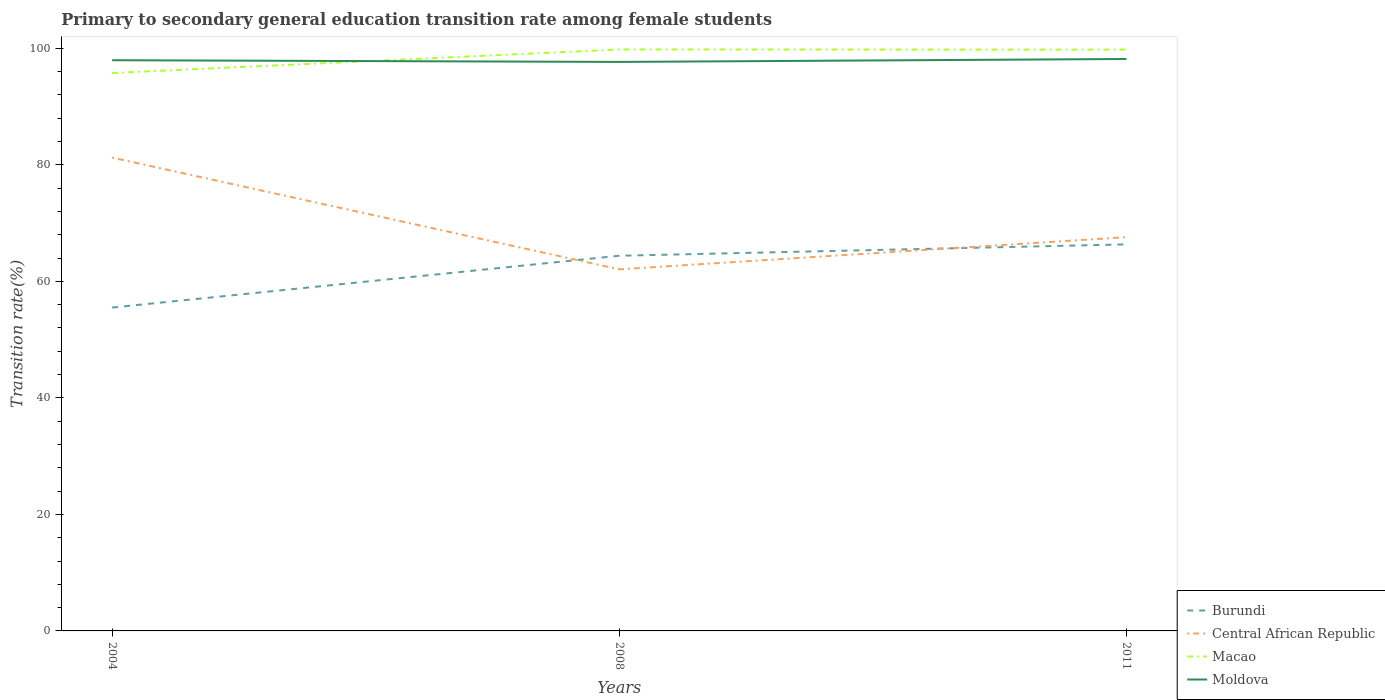How many different coloured lines are there?
Your response must be concise. 4. Does the line corresponding to Burundi intersect with the line corresponding to Central African Republic?
Ensure brevity in your answer.  Yes. Is the number of lines equal to the number of legend labels?
Give a very brief answer. Yes. Across all years, what is the maximum transition rate in Macao?
Keep it short and to the point. 95.75. In which year was the transition rate in Macao maximum?
Offer a terse response. 2004. What is the total transition rate in Burundi in the graph?
Offer a very short reply. -8.89. What is the difference between the highest and the second highest transition rate in Macao?
Your response must be concise. 4.04. What is the difference between the highest and the lowest transition rate in Burundi?
Offer a terse response. 2. What is the difference between two consecutive major ticks on the Y-axis?
Make the answer very short. 20. Are the values on the major ticks of Y-axis written in scientific E-notation?
Give a very brief answer. No. Does the graph contain grids?
Provide a succinct answer. No. Where does the legend appear in the graph?
Keep it short and to the point. Bottom right. How many legend labels are there?
Make the answer very short. 4. What is the title of the graph?
Your answer should be very brief. Primary to secondary general education transition rate among female students. What is the label or title of the X-axis?
Give a very brief answer. Years. What is the label or title of the Y-axis?
Keep it short and to the point. Transition rate(%). What is the Transition rate(%) of Burundi in 2004?
Offer a terse response. 55.49. What is the Transition rate(%) of Central African Republic in 2004?
Your answer should be compact. 81.23. What is the Transition rate(%) of Macao in 2004?
Ensure brevity in your answer.  95.75. What is the Transition rate(%) of Moldova in 2004?
Your response must be concise. 97.95. What is the Transition rate(%) of Burundi in 2008?
Your answer should be very brief. 64.39. What is the Transition rate(%) in Central African Republic in 2008?
Make the answer very short. 62.06. What is the Transition rate(%) in Macao in 2008?
Provide a short and direct response. 99.79. What is the Transition rate(%) in Moldova in 2008?
Your response must be concise. 97.65. What is the Transition rate(%) of Burundi in 2011?
Your answer should be compact. 66.34. What is the Transition rate(%) in Central African Republic in 2011?
Keep it short and to the point. 67.58. What is the Transition rate(%) in Macao in 2011?
Offer a very short reply. 99.76. What is the Transition rate(%) of Moldova in 2011?
Provide a short and direct response. 98.16. Across all years, what is the maximum Transition rate(%) of Burundi?
Provide a short and direct response. 66.34. Across all years, what is the maximum Transition rate(%) of Central African Republic?
Provide a succinct answer. 81.23. Across all years, what is the maximum Transition rate(%) in Macao?
Your answer should be very brief. 99.79. Across all years, what is the maximum Transition rate(%) in Moldova?
Provide a short and direct response. 98.16. Across all years, what is the minimum Transition rate(%) of Burundi?
Provide a short and direct response. 55.49. Across all years, what is the minimum Transition rate(%) of Central African Republic?
Your answer should be very brief. 62.06. Across all years, what is the minimum Transition rate(%) of Macao?
Your answer should be compact. 95.75. Across all years, what is the minimum Transition rate(%) of Moldova?
Provide a short and direct response. 97.65. What is the total Transition rate(%) in Burundi in the graph?
Offer a very short reply. 186.22. What is the total Transition rate(%) of Central African Republic in the graph?
Your answer should be very brief. 210.87. What is the total Transition rate(%) of Macao in the graph?
Your answer should be compact. 295.3. What is the total Transition rate(%) of Moldova in the graph?
Provide a succinct answer. 293.75. What is the difference between the Transition rate(%) in Burundi in 2004 and that in 2008?
Provide a short and direct response. -8.89. What is the difference between the Transition rate(%) in Central African Republic in 2004 and that in 2008?
Give a very brief answer. 19.18. What is the difference between the Transition rate(%) of Macao in 2004 and that in 2008?
Offer a terse response. -4.04. What is the difference between the Transition rate(%) of Moldova in 2004 and that in 2008?
Your response must be concise. 0.29. What is the difference between the Transition rate(%) in Burundi in 2004 and that in 2011?
Provide a short and direct response. -10.84. What is the difference between the Transition rate(%) in Central African Republic in 2004 and that in 2011?
Provide a short and direct response. 13.65. What is the difference between the Transition rate(%) in Macao in 2004 and that in 2011?
Keep it short and to the point. -4.01. What is the difference between the Transition rate(%) in Moldova in 2004 and that in 2011?
Give a very brief answer. -0.21. What is the difference between the Transition rate(%) in Burundi in 2008 and that in 2011?
Provide a succinct answer. -1.95. What is the difference between the Transition rate(%) of Central African Republic in 2008 and that in 2011?
Your response must be concise. -5.53. What is the difference between the Transition rate(%) of Macao in 2008 and that in 2011?
Ensure brevity in your answer.  0.02. What is the difference between the Transition rate(%) in Moldova in 2008 and that in 2011?
Your response must be concise. -0.5. What is the difference between the Transition rate(%) in Burundi in 2004 and the Transition rate(%) in Central African Republic in 2008?
Provide a short and direct response. -6.56. What is the difference between the Transition rate(%) of Burundi in 2004 and the Transition rate(%) of Macao in 2008?
Ensure brevity in your answer.  -44.29. What is the difference between the Transition rate(%) of Burundi in 2004 and the Transition rate(%) of Moldova in 2008?
Ensure brevity in your answer.  -42.16. What is the difference between the Transition rate(%) of Central African Republic in 2004 and the Transition rate(%) of Macao in 2008?
Your answer should be compact. -18.55. What is the difference between the Transition rate(%) of Central African Republic in 2004 and the Transition rate(%) of Moldova in 2008?
Keep it short and to the point. -16.42. What is the difference between the Transition rate(%) in Macao in 2004 and the Transition rate(%) in Moldova in 2008?
Provide a short and direct response. -1.9. What is the difference between the Transition rate(%) of Burundi in 2004 and the Transition rate(%) of Central African Republic in 2011?
Keep it short and to the point. -12.09. What is the difference between the Transition rate(%) in Burundi in 2004 and the Transition rate(%) in Macao in 2011?
Offer a very short reply. -44.27. What is the difference between the Transition rate(%) in Burundi in 2004 and the Transition rate(%) in Moldova in 2011?
Provide a short and direct response. -42.66. What is the difference between the Transition rate(%) in Central African Republic in 2004 and the Transition rate(%) in Macao in 2011?
Keep it short and to the point. -18.53. What is the difference between the Transition rate(%) of Central African Republic in 2004 and the Transition rate(%) of Moldova in 2011?
Offer a very short reply. -16.92. What is the difference between the Transition rate(%) in Macao in 2004 and the Transition rate(%) in Moldova in 2011?
Offer a terse response. -2.41. What is the difference between the Transition rate(%) of Burundi in 2008 and the Transition rate(%) of Central African Republic in 2011?
Provide a short and direct response. -3.19. What is the difference between the Transition rate(%) in Burundi in 2008 and the Transition rate(%) in Macao in 2011?
Give a very brief answer. -35.38. What is the difference between the Transition rate(%) of Burundi in 2008 and the Transition rate(%) of Moldova in 2011?
Your answer should be compact. -33.77. What is the difference between the Transition rate(%) of Central African Republic in 2008 and the Transition rate(%) of Macao in 2011?
Your response must be concise. -37.71. What is the difference between the Transition rate(%) of Central African Republic in 2008 and the Transition rate(%) of Moldova in 2011?
Offer a very short reply. -36.1. What is the difference between the Transition rate(%) of Macao in 2008 and the Transition rate(%) of Moldova in 2011?
Your answer should be compact. 1.63. What is the average Transition rate(%) of Burundi per year?
Offer a very short reply. 62.07. What is the average Transition rate(%) of Central African Republic per year?
Your answer should be very brief. 70.29. What is the average Transition rate(%) in Macao per year?
Your answer should be compact. 98.43. What is the average Transition rate(%) of Moldova per year?
Provide a short and direct response. 97.92. In the year 2004, what is the difference between the Transition rate(%) of Burundi and Transition rate(%) of Central African Republic?
Your response must be concise. -25.74. In the year 2004, what is the difference between the Transition rate(%) of Burundi and Transition rate(%) of Macao?
Your response must be concise. -40.26. In the year 2004, what is the difference between the Transition rate(%) in Burundi and Transition rate(%) in Moldova?
Make the answer very short. -42.45. In the year 2004, what is the difference between the Transition rate(%) of Central African Republic and Transition rate(%) of Macao?
Keep it short and to the point. -14.52. In the year 2004, what is the difference between the Transition rate(%) in Central African Republic and Transition rate(%) in Moldova?
Your response must be concise. -16.71. In the year 2004, what is the difference between the Transition rate(%) in Macao and Transition rate(%) in Moldova?
Your answer should be compact. -2.2. In the year 2008, what is the difference between the Transition rate(%) in Burundi and Transition rate(%) in Central African Republic?
Your answer should be very brief. 2.33. In the year 2008, what is the difference between the Transition rate(%) of Burundi and Transition rate(%) of Macao?
Offer a terse response. -35.4. In the year 2008, what is the difference between the Transition rate(%) in Burundi and Transition rate(%) in Moldova?
Make the answer very short. -33.26. In the year 2008, what is the difference between the Transition rate(%) of Central African Republic and Transition rate(%) of Macao?
Make the answer very short. -37.73. In the year 2008, what is the difference between the Transition rate(%) of Central African Republic and Transition rate(%) of Moldova?
Provide a short and direct response. -35.6. In the year 2008, what is the difference between the Transition rate(%) of Macao and Transition rate(%) of Moldova?
Make the answer very short. 2.14. In the year 2011, what is the difference between the Transition rate(%) in Burundi and Transition rate(%) in Central African Republic?
Keep it short and to the point. -1.24. In the year 2011, what is the difference between the Transition rate(%) in Burundi and Transition rate(%) in Macao?
Your response must be concise. -33.42. In the year 2011, what is the difference between the Transition rate(%) in Burundi and Transition rate(%) in Moldova?
Your answer should be very brief. -31.82. In the year 2011, what is the difference between the Transition rate(%) of Central African Republic and Transition rate(%) of Macao?
Make the answer very short. -32.18. In the year 2011, what is the difference between the Transition rate(%) of Central African Republic and Transition rate(%) of Moldova?
Make the answer very short. -30.57. In the year 2011, what is the difference between the Transition rate(%) in Macao and Transition rate(%) in Moldova?
Give a very brief answer. 1.61. What is the ratio of the Transition rate(%) of Burundi in 2004 to that in 2008?
Your answer should be compact. 0.86. What is the ratio of the Transition rate(%) in Central African Republic in 2004 to that in 2008?
Your response must be concise. 1.31. What is the ratio of the Transition rate(%) of Macao in 2004 to that in 2008?
Provide a succinct answer. 0.96. What is the ratio of the Transition rate(%) in Burundi in 2004 to that in 2011?
Ensure brevity in your answer.  0.84. What is the ratio of the Transition rate(%) of Central African Republic in 2004 to that in 2011?
Offer a very short reply. 1.2. What is the ratio of the Transition rate(%) of Macao in 2004 to that in 2011?
Your answer should be compact. 0.96. What is the ratio of the Transition rate(%) in Burundi in 2008 to that in 2011?
Ensure brevity in your answer.  0.97. What is the ratio of the Transition rate(%) in Central African Republic in 2008 to that in 2011?
Offer a very short reply. 0.92. What is the ratio of the Transition rate(%) of Moldova in 2008 to that in 2011?
Your answer should be very brief. 0.99. What is the difference between the highest and the second highest Transition rate(%) of Burundi?
Keep it short and to the point. 1.95. What is the difference between the highest and the second highest Transition rate(%) in Central African Republic?
Ensure brevity in your answer.  13.65. What is the difference between the highest and the second highest Transition rate(%) in Macao?
Make the answer very short. 0.02. What is the difference between the highest and the second highest Transition rate(%) of Moldova?
Offer a terse response. 0.21. What is the difference between the highest and the lowest Transition rate(%) of Burundi?
Provide a short and direct response. 10.84. What is the difference between the highest and the lowest Transition rate(%) of Central African Republic?
Provide a succinct answer. 19.18. What is the difference between the highest and the lowest Transition rate(%) of Macao?
Your answer should be compact. 4.04. What is the difference between the highest and the lowest Transition rate(%) of Moldova?
Keep it short and to the point. 0.5. 